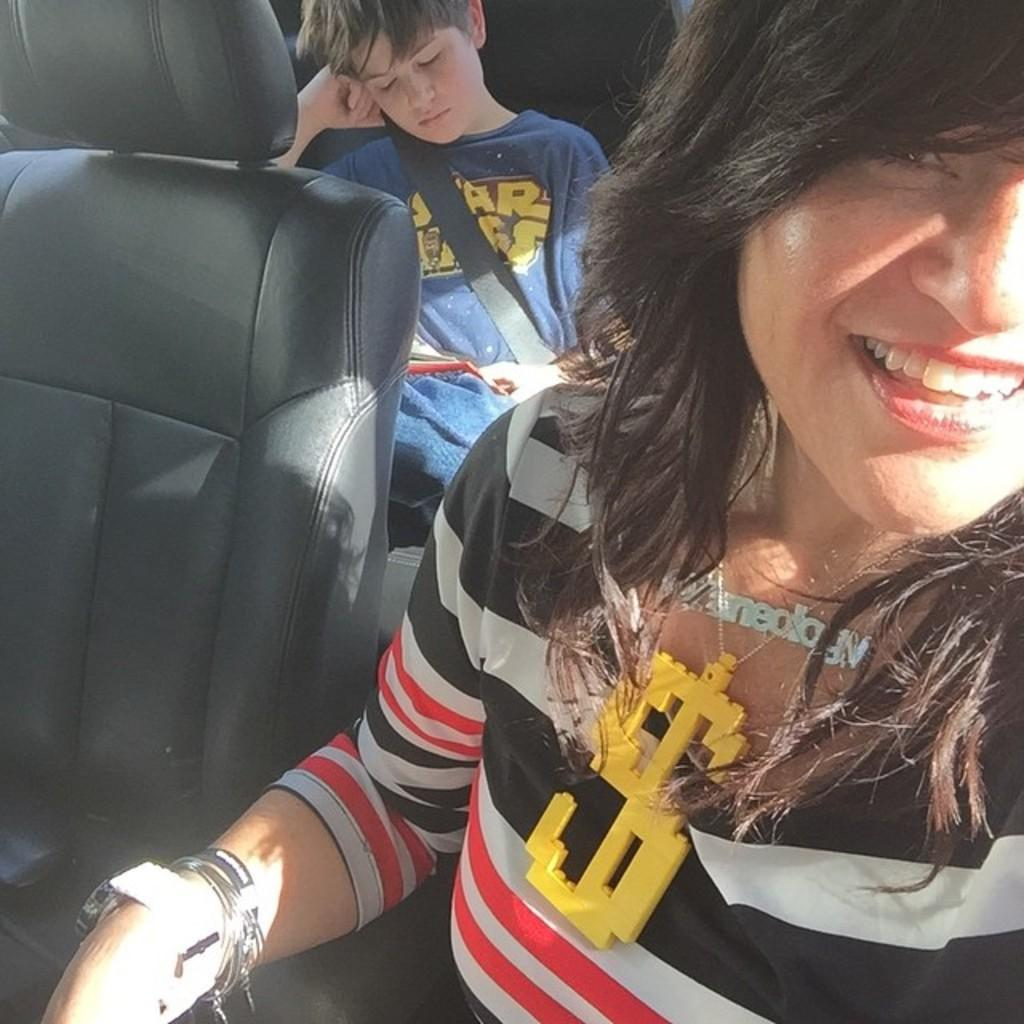Who is present in the image? There is a woman and a boy in the image. What are the woman and the boy doing in the image? Both the woman and the boy are sitting in a vehicle. How is the woman feeling in the image? The woman is smiling in the image. What type of floor can be seen in the image? There is no floor visible in the image, as both the woman and the boy are sitting in a vehicle. 